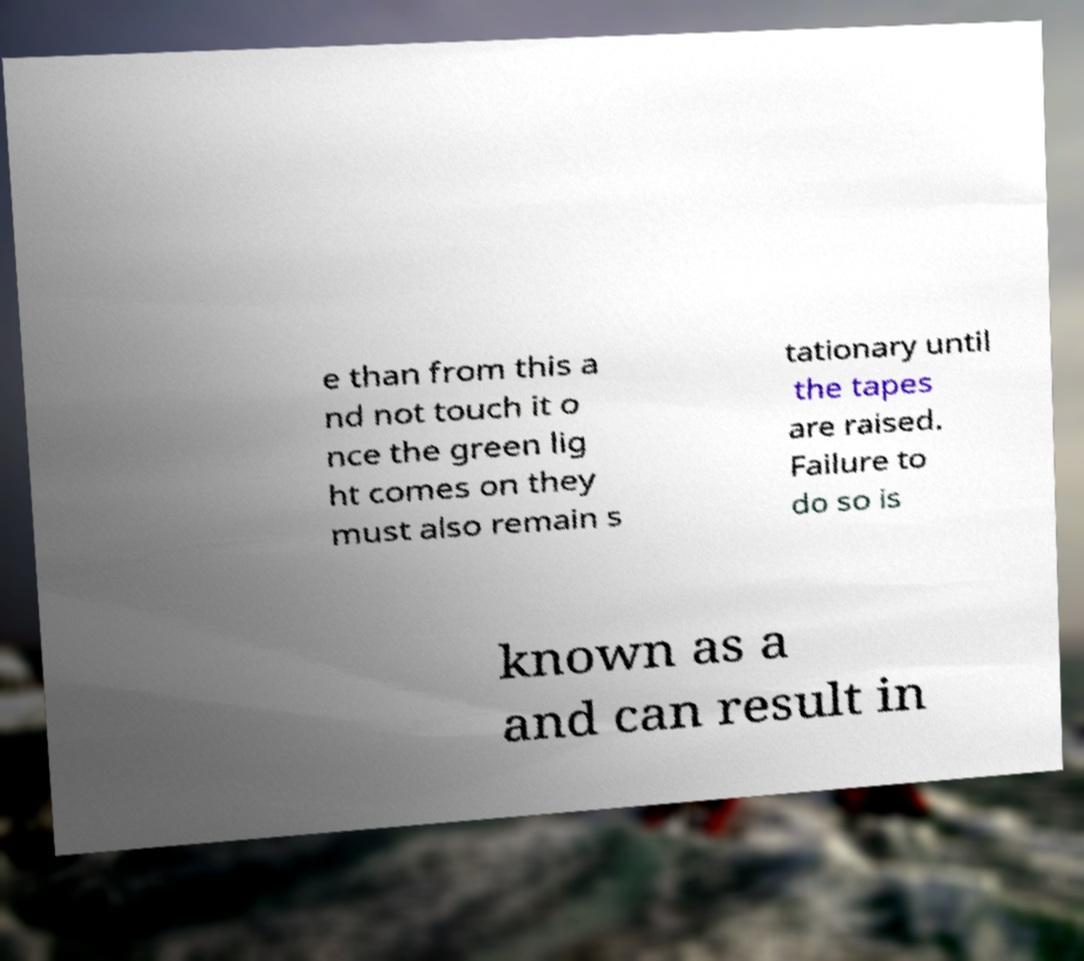I need the written content from this picture converted into text. Can you do that? e than from this a nd not touch it o nce the green lig ht comes on they must also remain s tationary until the tapes are raised. Failure to do so is known as a and can result in 